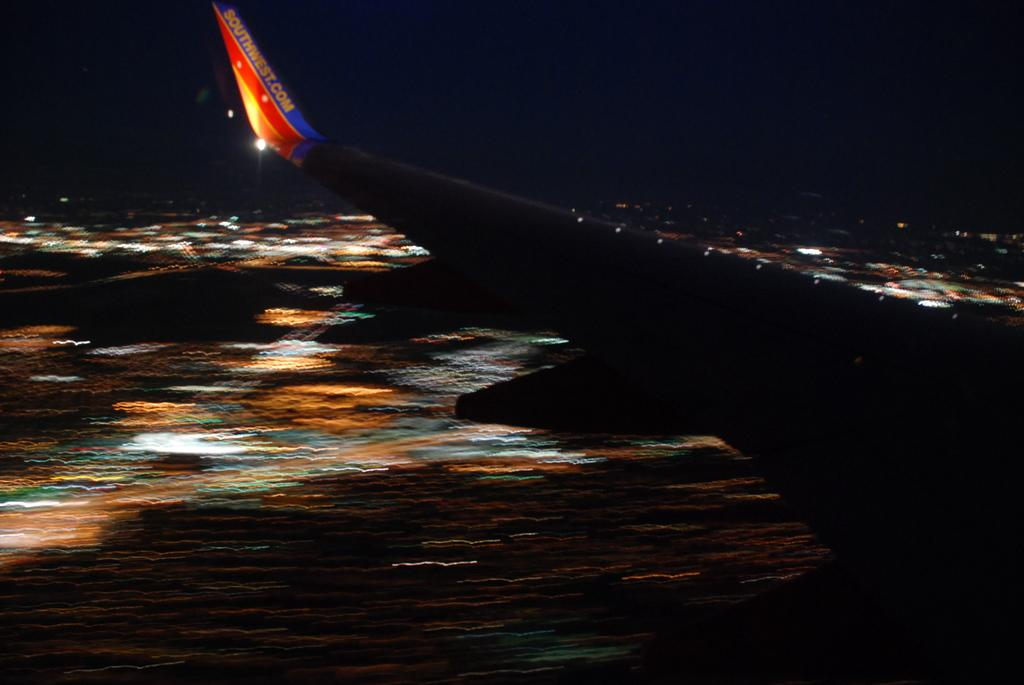<image>
Give a short and clear explanation of the subsequent image. A Southwest airplane is flying at night with the wing visible. 